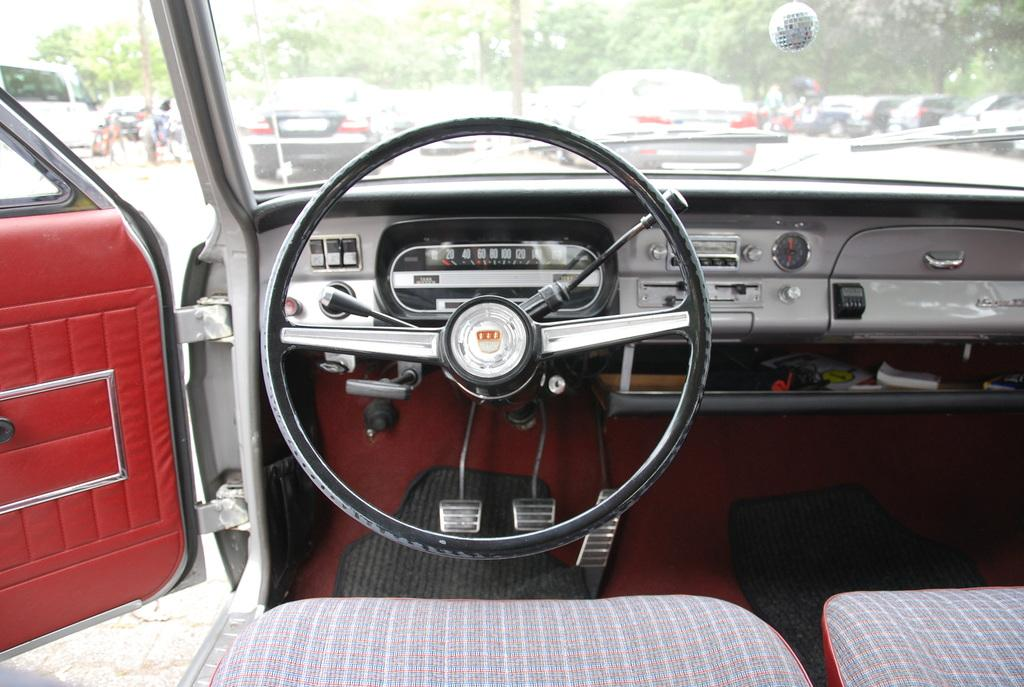What type of vehicle is shown in the image? The image shows the interior of a car. How many seats are in the car? There are 2 seats in the car. What is used to control the car's direction? There is a steering wheel in the car. What are the pedals at the bottom of the car used for? The clutch and brake are at the bottom of the car. Which door of the car is open? The left door of the car is open. What can be seen in the background of the image? There are poles, vehicles, and trees visible in the background. What type of property is being sold in the image? There is no property being sold in the image; it shows the interior of a car. What kind of soup is being served in the image? There is no soup present in the image. What type of beast can be seen in the background of the image? There are no beasts visible in the image; only poles, vehicles, and trees can be seen in the background. 